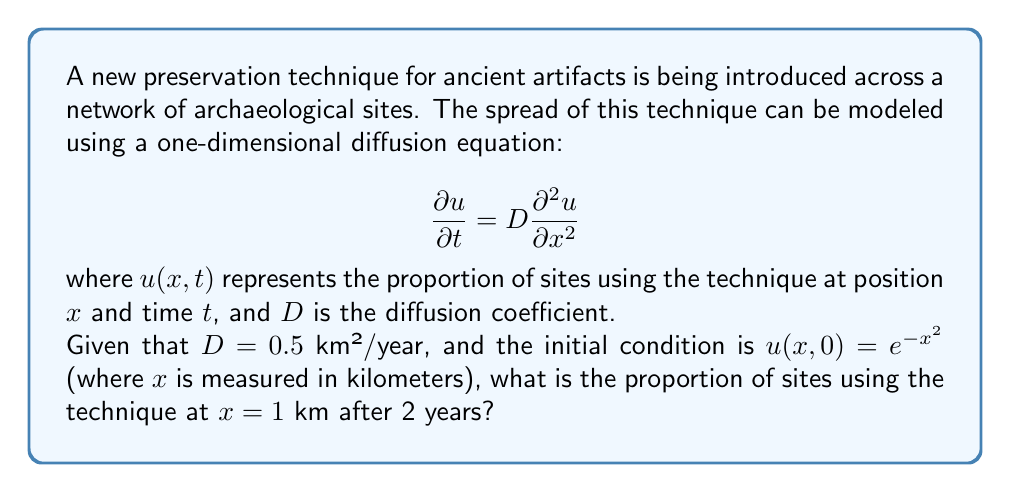What is the answer to this math problem? To solve this problem, we can use the fundamental solution of the diffusion equation, also known as the heat kernel. For an initial condition $u(x,0) = f(x)$, the solution at time $t$ is given by:

$$u(x,t) = \frac{1}{\sqrt{4\pi Dt}} \int_{-\infty}^{\infty} f(y) e^{-\frac{(x-y)^2}{4Dt}} dy$$

In our case:
$f(x) = e^{-x^2}$
$D = 0.5$ km²/year
$t = 2$ years
$x = 1$ km

Substituting these values:

$$u(1,2) = \frac{1}{\sqrt{4\pi (0.5)(2)}} \int_{-\infty}^{\infty} e^{-y^2} e^{-\frac{(1-y)^2}{4(0.5)(2)}} dy$$

Simplifying:

$$u(1,2) = \frac{1}{2\sqrt{\pi}} \int_{-\infty}^{\infty} e^{-y^2} e^{-\frac{(1-y)^2}{4}} dy$$

This integral can be evaluated analytically:

$$u(1,2) = \frac{1}{2\sqrt{\pi}} \cdot \sqrt{\frac{4\pi}{5}} \cdot e^{-\frac{1}{5}}$$

Simplifying:

$$u(1,2) = \frac{1}{\sqrt{5}} e^{-\frac{1}{5}}$$
Answer: $\frac{1}{\sqrt{5}} e^{-\frac{1}{5}} \approx 0.3768$

The proportion of sites using the preservation technique at $x = 1$ km after 2 years is approximately 0.3768 or 37.68%. 